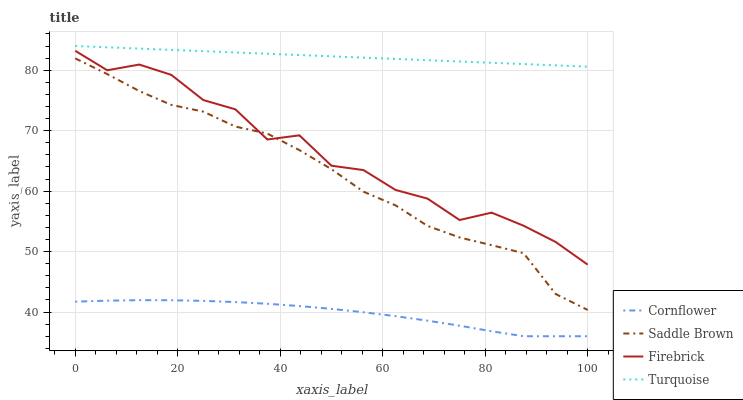Does Firebrick have the minimum area under the curve?
Answer yes or no. No. Does Firebrick have the maximum area under the curve?
Answer yes or no. No. Is Firebrick the smoothest?
Answer yes or no. No. Is Turquoise the roughest?
Answer yes or no. No. Does Firebrick have the lowest value?
Answer yes or no. No. Does Firebrick have the highest value?
Answer yes or no. No. Is Cornflower less than Turquoise?
Answer yes or no. Yes. Is Firebrick greater than Cornflower?
Answer yes or no. Yes. Does Cornflower intersect Turquoise?
Answer yes or no. No. 